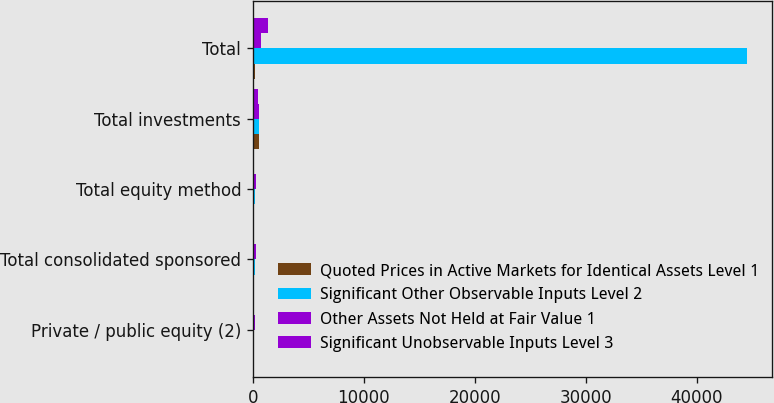Convert chart to OTSL. <chart><loc_0><loc_0><loc_500><loc_500><stacked_bar_chart><ecel><fcel>Private / public equity (2)<fcel>Total consolidated sponsored<fcel>Total equity method<fcel>Total investments<fcel>Total<nl><fcel>Quoted Prices in Active Markets for Identical Assets Level 1<fcel>5<fcel>5<fcel>132<fcel>590<fcel>223<nl><fcel>Significant Other Observable Inputs Level 2<fcel>13<fcel>148<fcel>197<fcel>571<fcel>44511<nl><fcel>Other Assets Not Held at Fair Value 1<fcel>223<fcel>247<fcel>298<fcel>574<fcel>752<nl><fcel>Significant Unobservable Inputs Level 3<fcel>41<fcel>41<fcel>70<fcel>416<fcel>1325<nl></chart> 